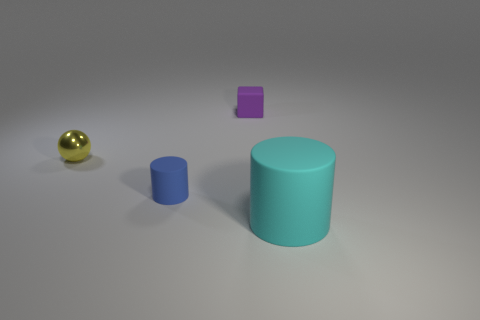What number of objects are cyan objects or objects that are to the right of the yellow metallic sphere?
Provide a short and direct response. 3. Are there more tiny blocks than cylinders?
Give a very brief answer. No. Is there another cylinder that has the same material as the blue cylinder?
Offer a very short reply. Yes. What is the shape of the small thing that is in front of the small purple block and on the right side of the small yellow shiny object?
Provide a short and direct response. Cylinder. How many other things are the same shape as the purple rubber object?
Make the answer very short. 0. What is the size of the cyan object?
Your answer should be very brief. Large. What number of objects are either small purple rubber cubes or large cyan metal things?
Make the answer very short. 1. There is a object that is behind the small yellow sphere; what is its size?
Give a very brief answer. Small. Are there any other things that have the same size as the cyan matte object?
Keep it short and to the point. No. The small thing that is both behind the blue object and on the left side of the purple thing is what color?
Make the answer very short. Yellow. 